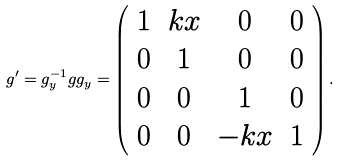Convert formula to latex. <formula><loc_0><loc_0><loc_500><loc_500>g ^ { \prime } = g _ { y } ^ { - 1 } g g _ { y } = \left ( \begin{array} { c c c c } 1 & k x & 0 & 0 \\ 0 & 1 & 0 & 0 \\ 0 & 0 & 1 & 0 \\ 0 & 0 & - k x & 1 \\ \end{array} \right ) .</formula> 